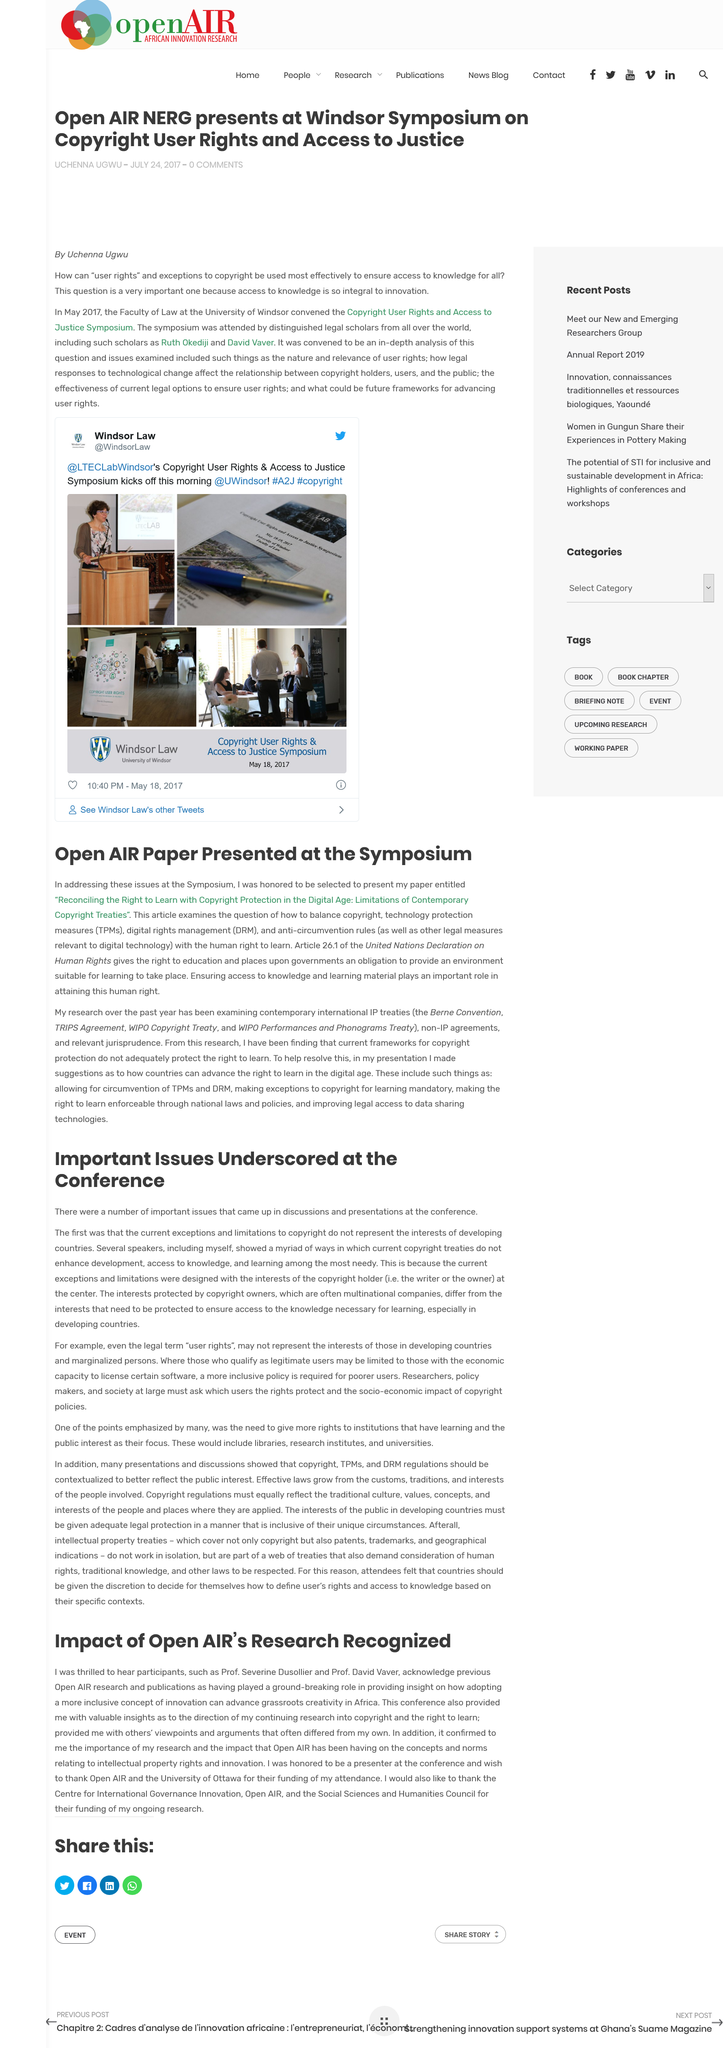Specify some key components in this picture. The acronym DRM stands for digital rights management. The first issue discussed at the conference was the fact that the current exceptions and limitations to copyright do not adequately represent the interests of developing countries. The impact of Open Air research was duly recognized. It is common for copyright ownership to be held by multinational companies, as per usual. The University of Ottawa was thanked for their funding. 